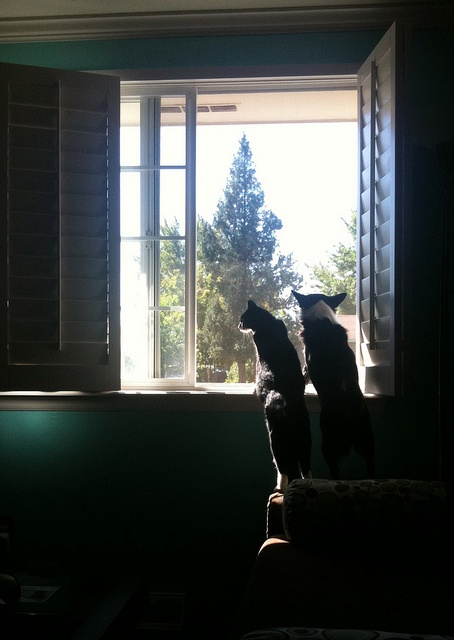Describe the objects in this image and their specific colors. I can see chair in gray, black, tan, and beige tones, dog in gray, black, navy, and lightgray tones, and cat in gray, black, lightgray, and darkgray tones in this image. 